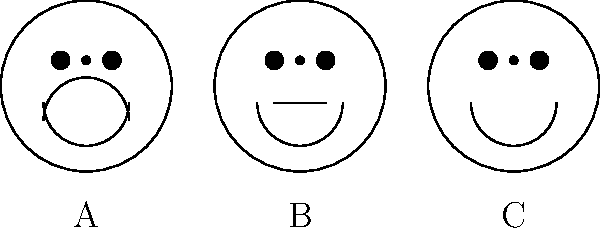As a psychologist working with individuals affected by human rights violations, you often encounter patients from diverse cultural backgrounds. In the image above, three facial expressions are shown. Which of these expressions (A, B, or C) would be most universally recognized across different cultures as indicating a positive emotional state? To answer this question, we need to consider the universal recognition of facial expressions across cultures:

1. Examine each facial expression:
   A: Downturned mouth, indicating sadness
   B: Straight mouth, indicating a neutral expression
   C: Upturned mouth, indicating happiness

2. Consider cross-cultural studies on facial expressions:
   - Research by Paul Ekman and others has shown that certain basic emotions, including happiness, are recognized universally across cultures.
   - The expression of happiness, characterized by an upturned mouth or smile, is one of the most consistently recognized emotions across different cultural contexts.

3. Evaluate the relevance to human rights work:
   - In counseling individuals affected by human rights violations, recognizing positive emotions is crucial for assessing recovery and resilience.
   - A universally recognized positive expression can be a valuable tool in cross-cultural therapeutic settings.

4. Conclude based on the evidence:
   - Expression C, with its upturned mouth (smile), represents happiness and is the most likely to be universally recognized as a positive emotional state across different cultures.
Answer: C 